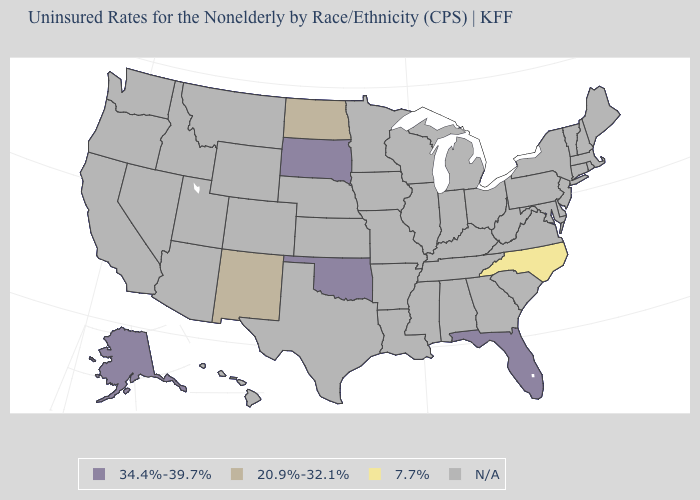What is the lowest value in the West?
Write a very short answer. 20.9%-32.1%. Does the first symbol in the legend represent the smallest category?
Concise answer only. No. What is the value of Nevada?
Keep it brief. N/A. What is the value of Alaska?
Short answer required. 34.4%-39.7%. What is the highest value in the West ?
Give a very brief answer. 34.4%-39.7%. What is the value of Mississippi?
Give a very brief answer. N/A. Does the map have missing data?
Quick response, please. Yes. Does Florida have the highest value in the USA?
Quick response, please. Yes. Which states have the highest value in the USA?
Write a very short answer. Alaska, Florida, Oklahoma, South Dakota. What is the value of Wyoming?
Concise answer only. N/A. Which states have the lowest value in the MidWest?
Write a very short answer. North Dakota. Name the states that have a value in the range 34.4%-39.7%?
Short answer required. Alaska, Florida, Oklahoma, South Dakota. Name the states that have a value in the range 34.4%-39.7%?
Answer briefly. Alaska, Florida, Oklahoma, South Dakota. 